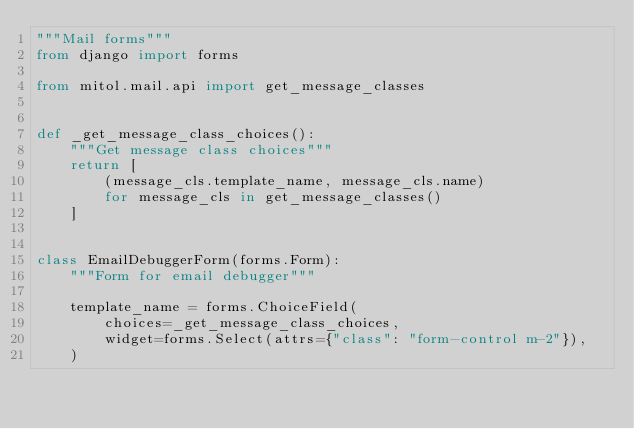<code> <loc_0><loc_0><loc_500><loc_500><_Python_>"""Mail forms"""
from django import forms

from mitol.mail.api import get_message_classes


def _get_message_class_choices():
    """Get message class choices"""
    return [
        (message_cls.template_name, message_cls.name)
        for message_cls in get_message_classes()
    ]


class EmailDebuggerForm(forms.Form):
    """Form for email debugger"""

    template_name = forms.ChoiceField(
        choices=_get_message_class_choices,
        widget=forms.Select(attrs={"class": "form-control m-2"}),
    )
</code> 